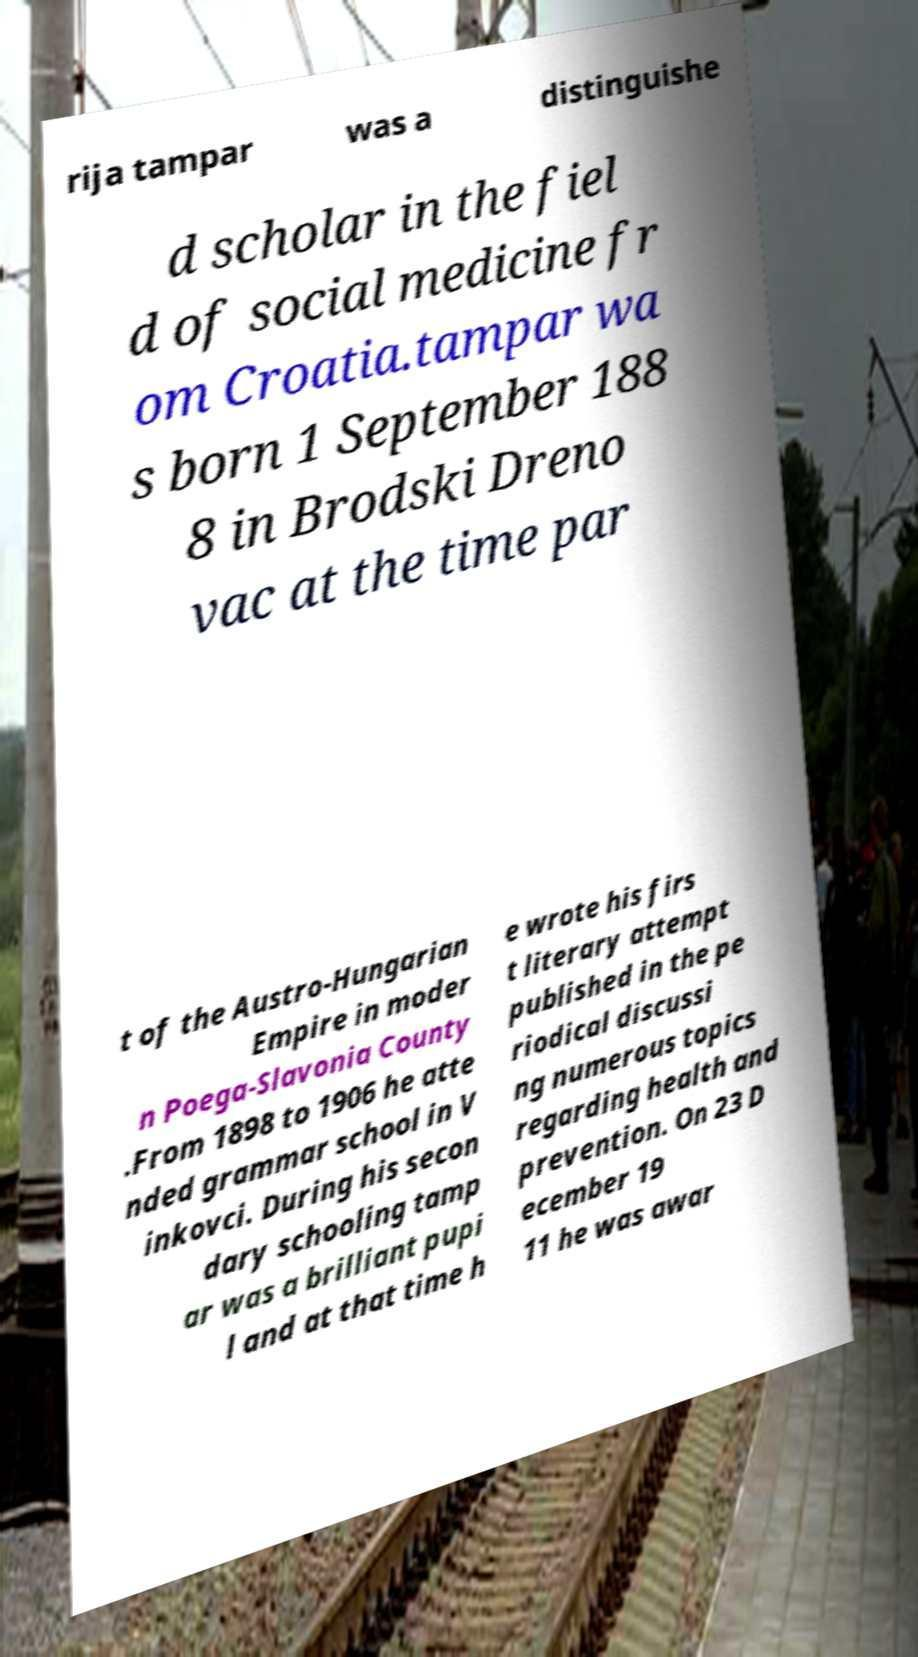Can you read and provide the text displayed in the image?This photo seems to have some interesting text. Can you extract and type it out for me? rija tampar was a distinguishe d scholar in the fiel d of social medicine fr om Croatia.tampar wa s born 1 September 188 8 in Brodski Dreno vac at the time par t of the Austro-Hungarian Empire in moder n Poega-Slavonia County .From 1898 to 1906 he atte nded grammar school in V inkovci. During his secon dary schooling tamp ar was a brilliant pupi l and at that time h e wrote his firs t literary attempt published in the pe riodical discussi ng numerous topics regarding health and prevention. On 23 D ecember 19 11 he was awar 